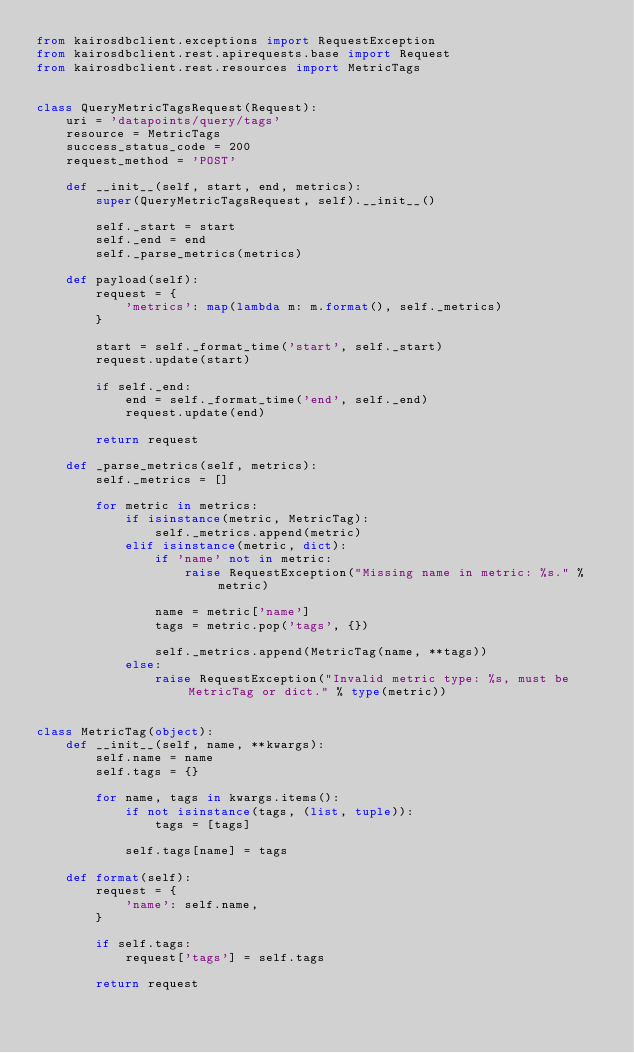Convert code to text. <code><loc_0><loc_0><loc_500><loc_500><_Python_>from kairosdbclient.exceptions import RequestException
from kairosdbclient.rest.apirequests.base import Request
from kairosdbclient.rest.resources import MetricTags


class QueryMetricTagsRequest(Request):
    uri = 'datapoints/query/tags'
    resource = MetricTags
    success_status_code = 200
    request_method = 'POST'

    def __init__(self, start, end, metrics):
        super(QueryMetricTagsRequest, self).__init__()

        self._start = start
        self._end = end
        self._parse_metrics(metrics)

    def payload(self):
        request = {
            'metrics': map(lambda m: m.format(), self._metrics)
        }

        start = self._format_time('start', self._start)
        request.update(start)

        if self._end:
            end = self._format_time('end', self._end)
            request.update(end)

        return request

    def _parse_metrics(self, metrics):
        self._metrics = []

        for metric in metrics:
            if isinstance(metric, MetricTag):
                self._metrics.append(metric)
            elif isinstance(metric, dict):
                if 'name' not in metric:
                    raise RequestException("Missing name in metric: %s." % metric)

                name = metric['name']
                tags = metric.pop('tags', {})

                self._metrics.append(MetricTag(name, **tags))
            else:
                raise RequestException("Invalid metric type: %s, must be MetricTag or dict." % type(metric))


class MetricTag(object):
    def __init__(self, name, **kwargs):
        self.name = name
        self.tags = {}

        for name, tags in kwargs.items():
            if not isinstance(tags, (list, tuple)):
                tags = [tags]

            self.tags[name] = tags

    def format(self):
        request = {
            'name': self.name,
        }

        if self.tags:
            request['tags'] = self.tags

        return request</code> 